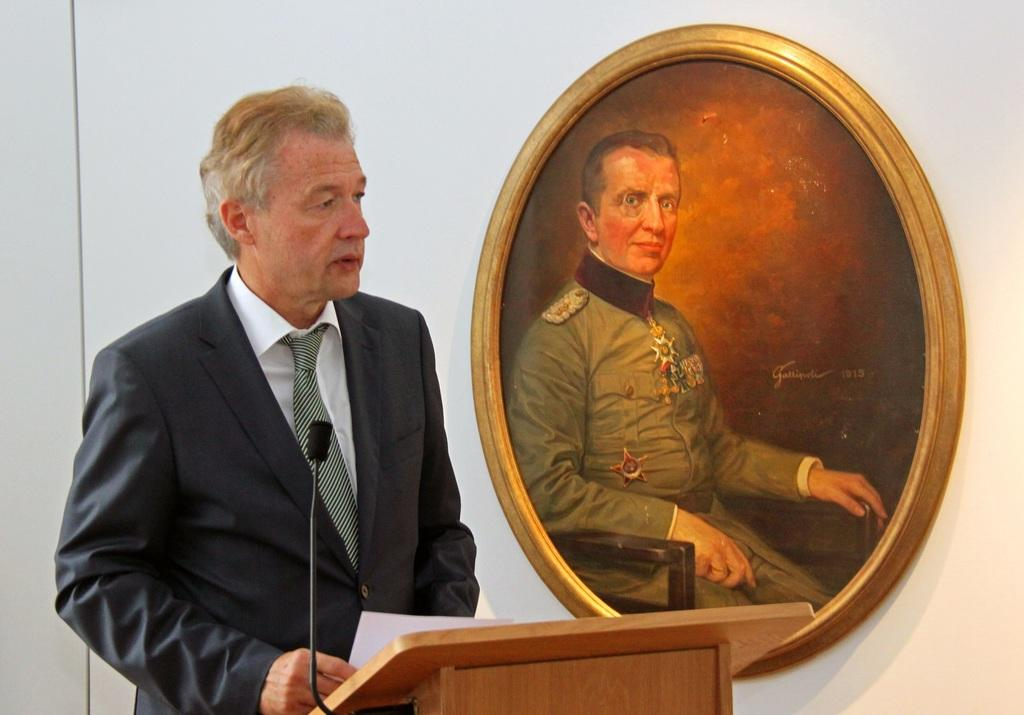What is present in the image that serves as a background? There is a wall in the image that serves as a background. What object can be seen hanging on the wall? There is a photo frame in the image hanging on the wall. Who is present in the image? There is a man in the image. What is the man wearing? The man is wearing a black jacket. What is the man holding in the image? The man is holding a paper. What object is present in the image that is typically used for amplifying sound? There is a microphone (mic) in the image. What type of sweater is the man wearing in the image? The man is not wearing a sweater in the image; he is wearing a black jacket. What type of border can be seen around the photo frame in the image? There is no information about the border around the photo frame in the image, as it is not mentioned in the provided facts. 